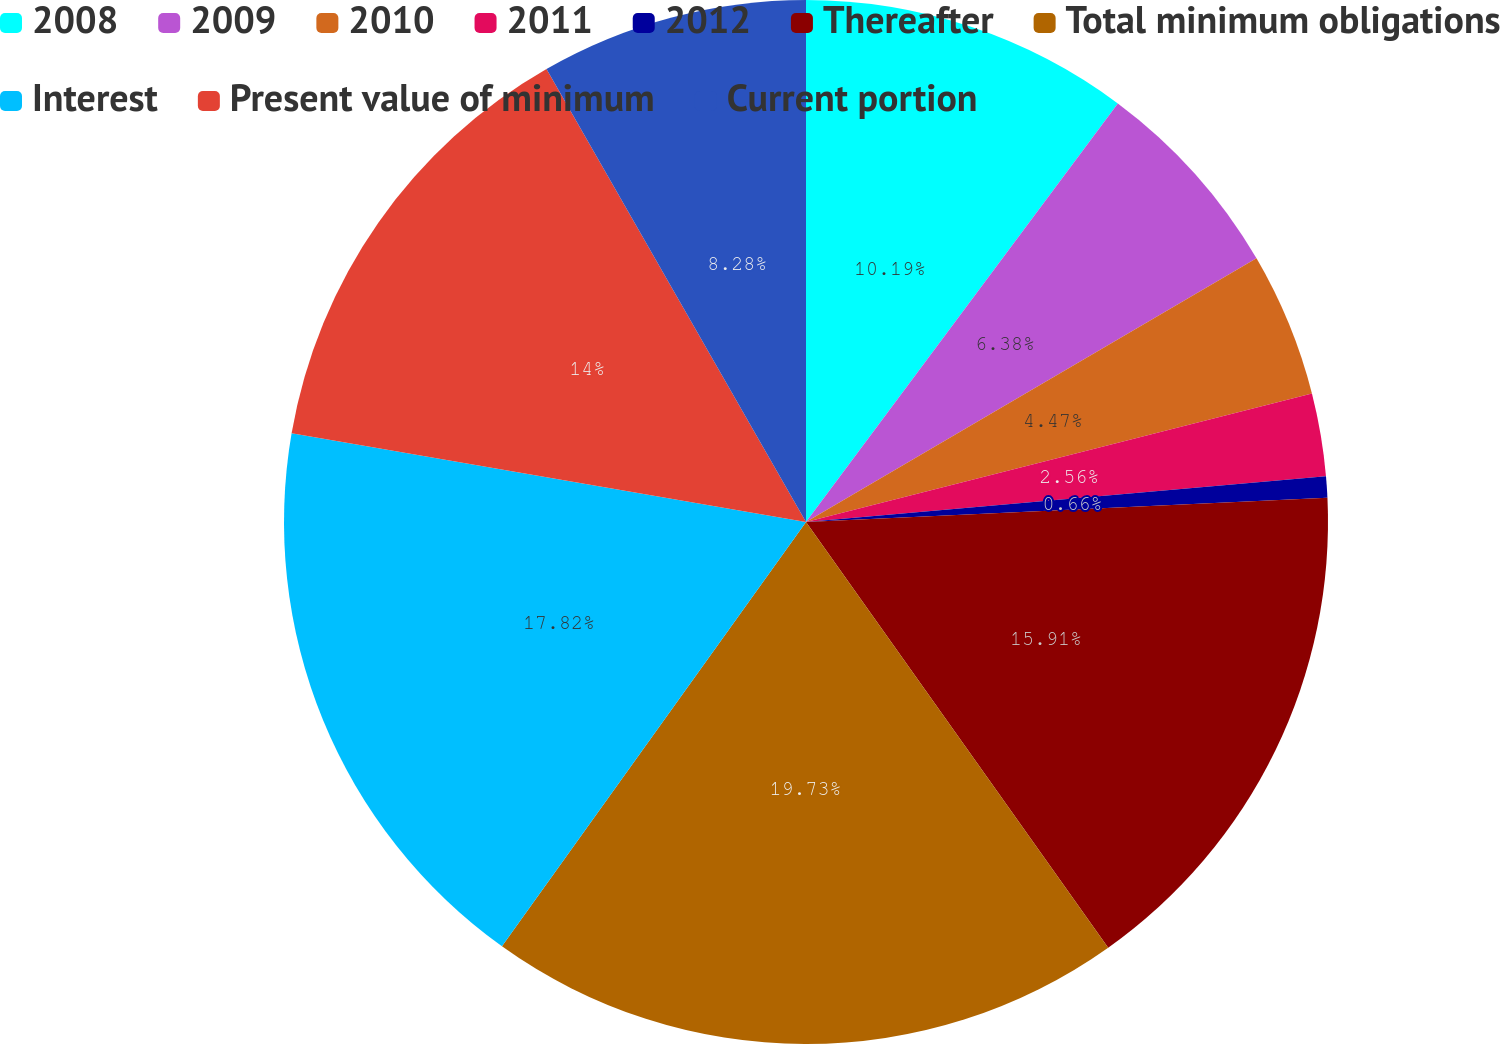Convert chart. <chart><loc_0><loc_0><loc_500><loc_500><pie_chart><fcel>2008<fcel>2009<fcel>2010<fcel>2011<fcel>2012<fcel>Thereafter<fcel>Total minimum obligations<fcel>Interest<fcel>Present value of minimum<fcel>Current portion<nl><fcel>10.19%<fcel>6.38%<fcel>4.47%<fcel>2.56%<fcel>0.66%<fcel>15.91%<fcel>19.72%<fcel>17.82%<fcel>14.0%<fcel>8.28%<nl></chart> 